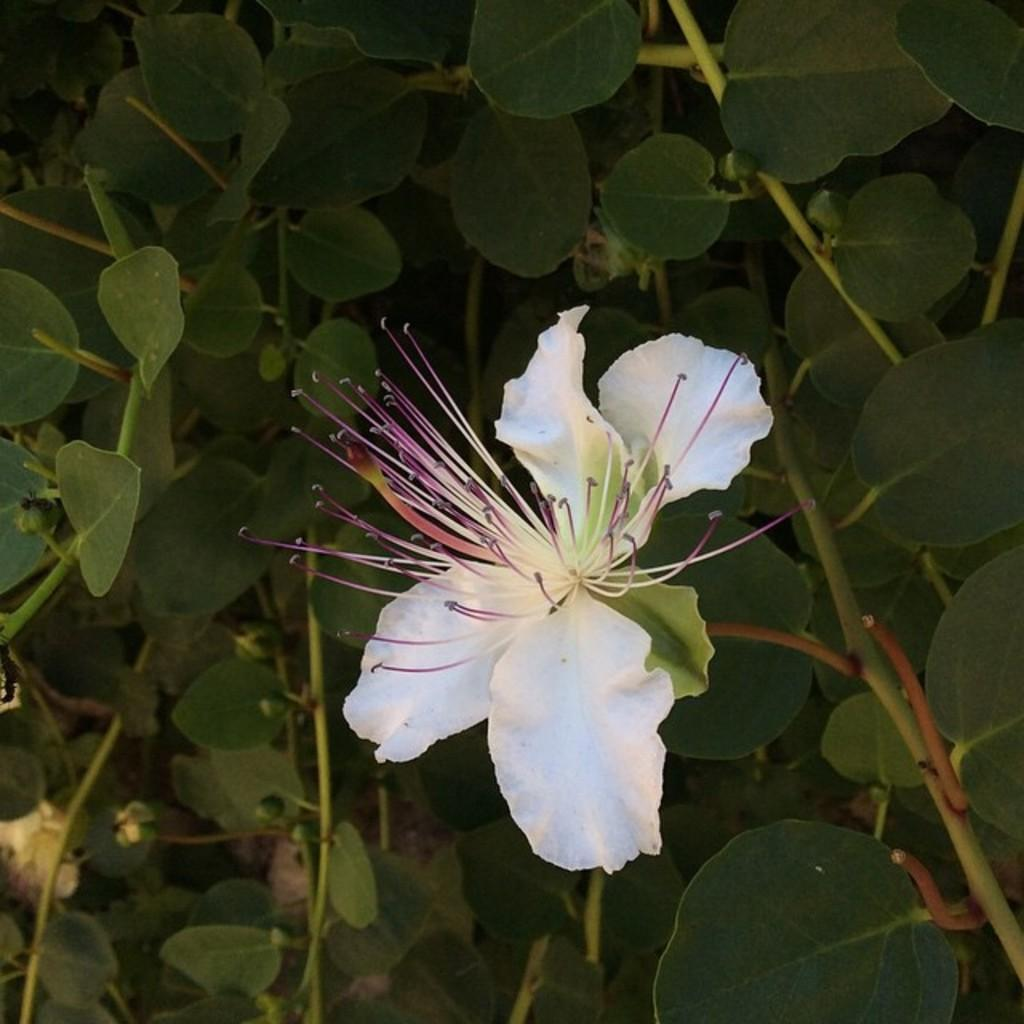What type of plant material is present in the image? There are green leaves on stems in the image. What additional feature can be seen in the image? There is a flower in the image. What colors are present in the flower? The flower has white and violet colors. What type of drink is being served on the table in the image? There is no table or drink present in the image; it only features green leaves, a flower, and the colors white and violet. 